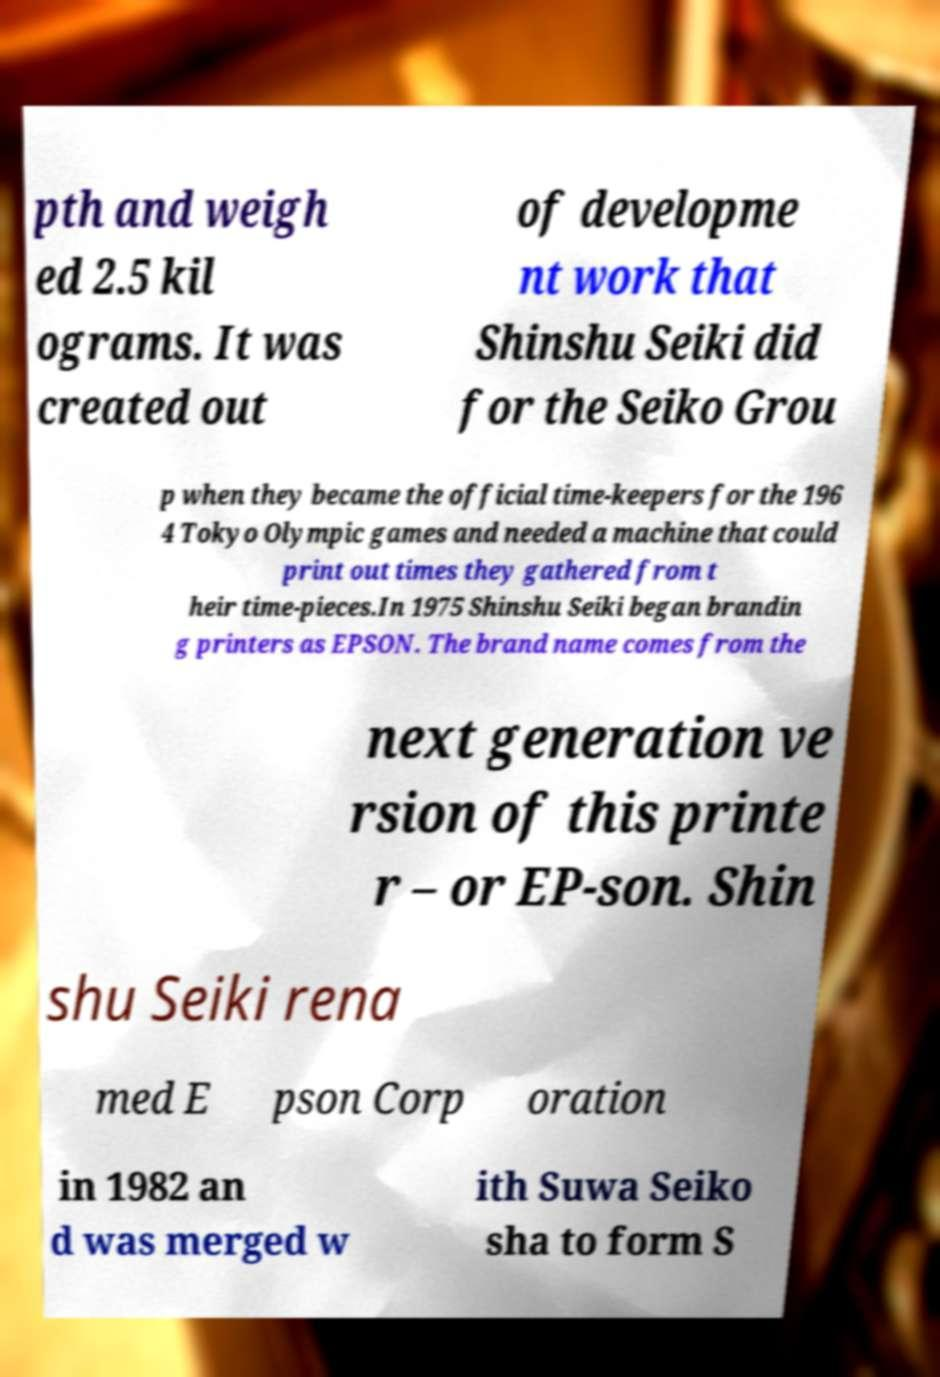Please identify and transcribe the text found in this image. pth and weigh ed 2.5 kil ograms. It was created out of developme nt work that Shinshu Seiki did for the Seiko Grou p when they became the official time-keepers for the 196 4 Tokyo Olympic games and needed a machine that could print out times they gathered from t heir time-pieces.In 1975 Shinshu Seiki began brandin g printers as EPSON. The brand name comes from the next generation ve rsion of this printe r – or EP-son. Shin shu Seiki rena med E pson Corp oration in 1982 an d was merged w ith Suwa Seiko sha to form S 